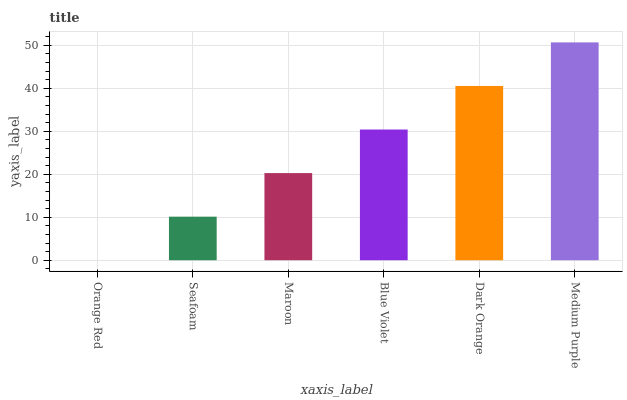Is Orange Red the minimum?
Answer yes or no. Yes. Is Medium Purple the maximum?
Answer yes or no. Yes. Is Seafoam the minimum?
Answer yes or no. No. Is Seafoam the maximum?
Answer yes or no. No. Is Seafoam greater than Orange Red?
Answer yes or no. Yes. Is Orange Red less than Seafoam?
Answer yes or no. Yes. Is Orange Red greater than Seafoam?
Answer yes or no. No. Is Seafoam less than Orange Red?
Answer yes or no. No. Is Blue Violet the high median?
Answer yes or no. Yes. Is Maroon the low median?
Answer yes or no. Yes. Is Orange Red the high median?
Answer yes or no. No. Is Seafoam the low median?
Answer yes or no. No. 